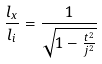<formula> <loc_0><loc_0><loc_500><loc_500>\frac { l _ { x } } { l _ { i } } = \frac { 1 } { \sqrt { 1 - \frac { t ^ { 2 } } { j ^ { 2 } } } }</formula> 